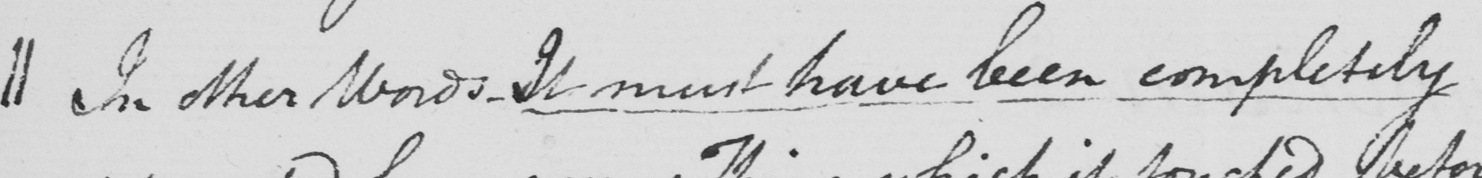Can you tell me what this handwritten text says? || In other words , It must have been completely 